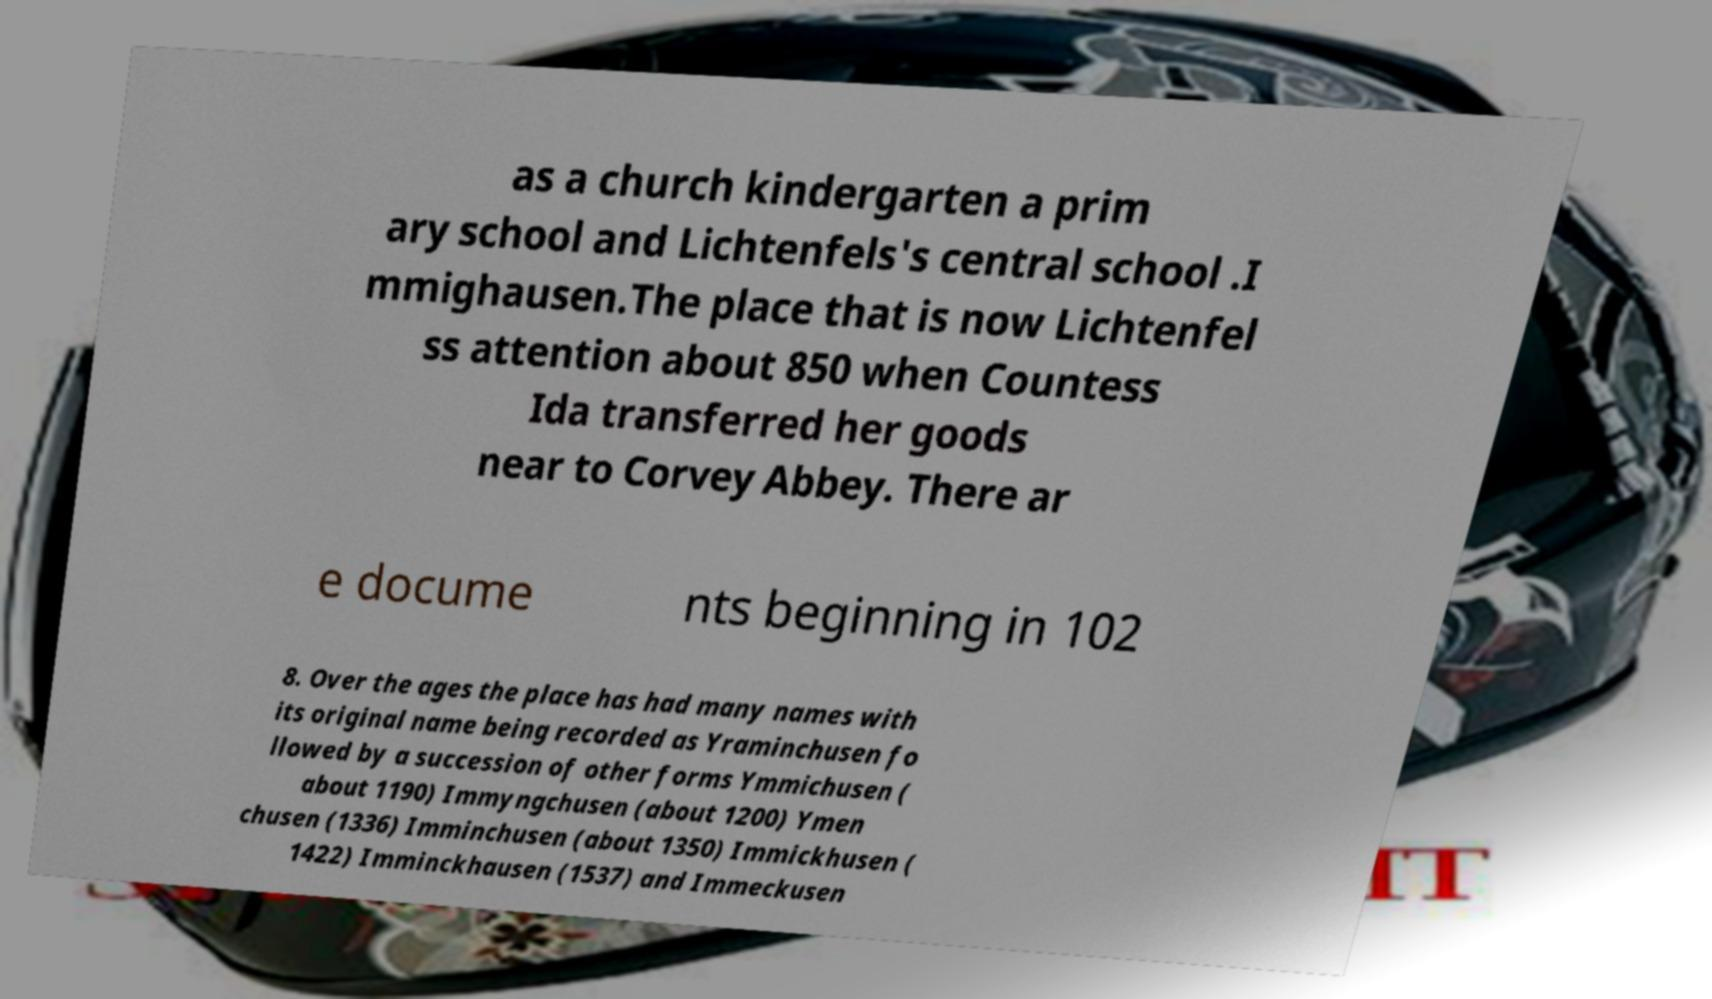Can you accurately transcribe the text from the provided image for me? as a church kindergarten a prim ary school and Lichtenfels's central school .I mmighausen.The place that is now Lichtenfel ss attention about 850 when Countess Ida transferred her goods near to Corvey Abbey. There ar e docume nts beginning in 102 8. Over the ages the place has had many names with its original name being recorded as Yraminchusen fo llowed by a succession of other forms Ymmichusen ( about 1190) Immyngchusen (about 1200) Ymen chusen (1336) Imminchusen (about 1350) Immickhusen ( 1422) Imminckhausen (1537) and Immeckusen 